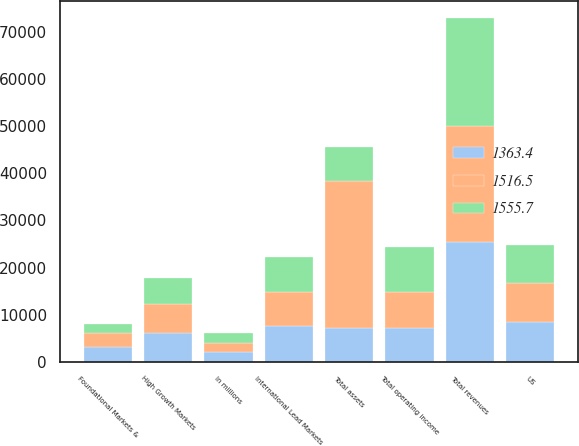Convert chart to OTSL. <chart><loc_0><loc_0><loc_500><loc_500><stacked_bar_chart><ecel><fcel>In millions<fcel>US<fcel>International Lead Markets<fcel>High Growth Markets<fcel>Foundational Markets &<fcel>Total revenues<fcel>Total operating income<fcel>Total assets<nl><fcel>1555.7<fcel>2017<fcel>8006.4<fcel>7340.3<fcel>5533.2<fcel>1940.5<fcel>22820.4<fcel>9552.7<fcel>7281.85<nl><fcel>1516.5<fcel>2016<fcel>8252.7<fcel>7223.4<fcel>6160.7<fcel>2985.1<fcel>24621.9<fcel>7744.5<fcel>31023.9<nl><fcel>1363.4<fcel>2015<fcel>8558.9<fcel>7614.9<fcel>6172.8<fcel>3066.4<fcel>25413<fcel>7145.5<fcel>7281.85<nl></chart> 